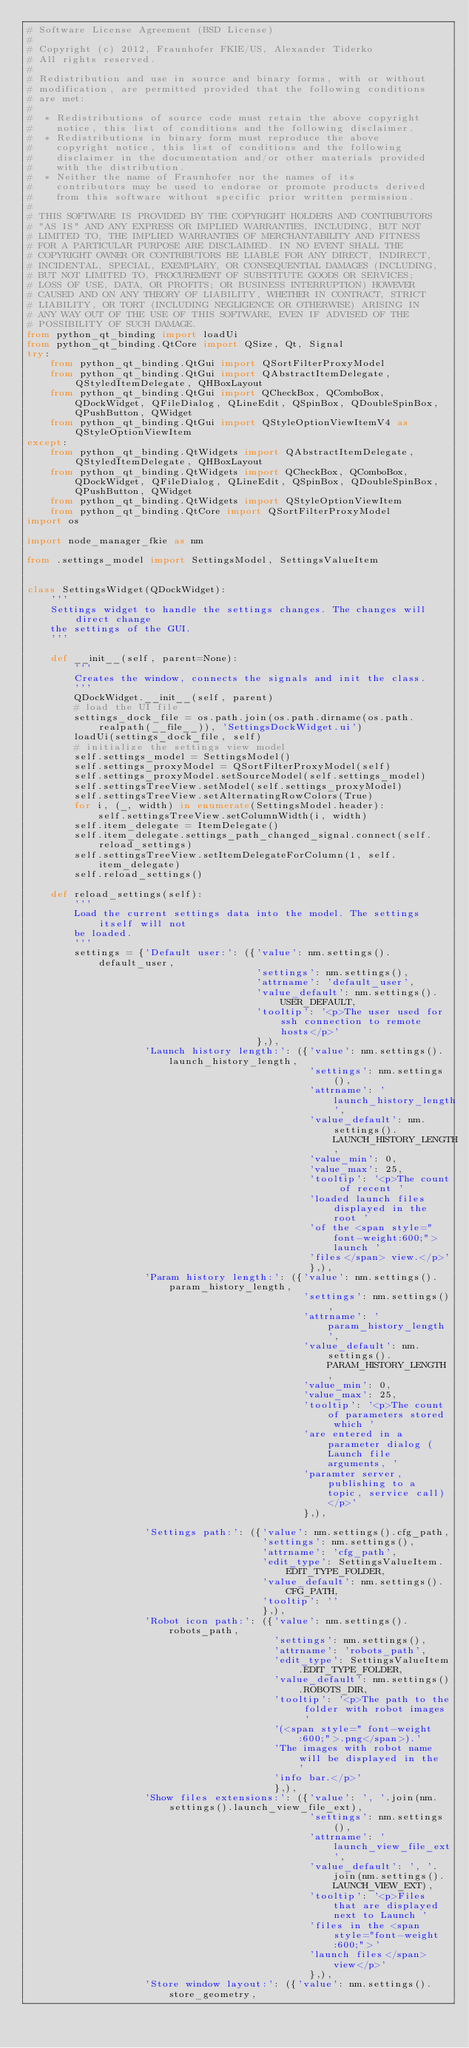<code> <loc_0><loc_0><loc_500><loc_500><_Python_># Software License Agreement (BSD License)
#
# Copyright (c) 2012, Fraunhofer FKIE/US, Alexander Tiderko
# All rights reserved.
#
# Redistribution and use in source and binary forms, with or without
# modification, are permitted provided that the following conditions
# are met:
#
#  * Redistributions of source code must retain the above copyright
#    notice, this list of conditions and the following disclaimer.
#  * Redistributions in binary form must reproduce the above
#    copyright notice, this list of conditions and the following
#    disclaimer in the documentation and/or other materials provided
#    with the distribution.
#  * Neither the name of Fraunhofer nor the names of its
#    contributors may be used to endorse or promote products derived
#    from this software without specific prior written permission.
#
# THIS SOFTWARE IS PROVIDED BY THE COPYRIGHT HOLDERS AND CONTRIBUTORS
# "AS IS" AND ANY EXPRESS OR IMPLIED WARRANTIES, INCLUDING, BUT NOT
# LIMITED TO, THE IMPLIED WARRANTIES OF MERCHANTABILITY AND FITNESS
# FOR A PARTICULAR PURPOSE ARE DISCLAIMED. IN NO EVENT SHALL THE
# COPYRIGHT OWNER OR CONTRIBUTORS BE LIABLE FOR ANY DIRECT, INDIRECT,
# INCIDENTAL, SPECIAL, EXEMPLARY, OR CONSEQUENTIAL DAMAGES (INCLUDING,
# BUT NOT LIMITED TO, PROCUREMENT OF SUBSTITUTE GOODS OR SERVICES;
# LOSS OF USE, DATA, OR PROFITS; OR BUSINESS INTERRUPTION) HOWEVER
# CAUSED AND ON ANY THEORY OF LIABILITY, WHETHER IN CONTRACT, STRICT
# LIABILITY, OR TORT (INCLUDING NEGLIGENCE OR OTHERWISE) ARISING IN
# ANY WAY OUT OF THE USE OF THIS SOFTWARE, EVEN IF ADVISED OF THE
# POSSIBILITY OF SUCH DAMAGE.
from python_qt_binding import loadUi
from python_qt_binding.QtCore import QSize, Qt, Signal
try:
    from python_qt_binding.QtGui import QSortFilterProxyModel
    from python_qt_binding.QtGui import QAbstractItemDelegate, QStyledItemDelegate, QHBoxLayout
    from python_qt_binding.QtGui import QCheckBox, QComboBox, QDockWidget, QFileDialog, QLineEdit, QSpinBox, QDoubleSpinBox, QPushButton, QWidget
    from python_qt_binding.QtGui import QStyleOptionViewItemV4 as QStyleOptionViewItem
except:
    from python_qt_binding.QtWidgets import QAbstractItemDelegate, QStyledItemDelegate, QHBoxLayout
    from python_qt_binding.QtWidgets import QCheckBox, QComboBox, QDockWidget, QFileDialog, QLineEdit, QSpinBox, QDoubleSpinBox, QPushButton, QWidget
    from python_qt_binding.QtWidgets import QStyleOptionViewItem
    from python_qt_binding.QtCore import QSortFilterProxyModel
import os

import node_manager_fkie as nm

from .settings_model import SettingsModel, SettingsValueItem


class SettingsWidget(QDockWidget):
    '''
    Settings widget to handle the settings changes. The changes will direct change
    the settings of the GUI.
    '''

    def __init__(self, parent=None):
        '''
        Creates the window, connects the signals and init the class.
        '''
        QDockWidget.__init__(self, parent)
        # load the UI file
        settings_dock_file = os.path.join(os.path.dirname(os.path.realpath(__file__)), 'SettingsDockWidget.ui')
        loadUi(settings_dock_file, self)
        # initialize the settings view model
        self.settings_model = SettingsModel()
        self.settings_proxyModel = QSortFilterProxyModel(self)
        self.settings_proxyModel.setSourceModel(self.settings_model)
        self.settingsTreeView.setModel(self.settings_proxyModel)
        self.settingsTreeView.setAlternatingRowColors(True)
        for i, (_, width) in enumerate(SettingsModel.header):
            self.settingsTreeView.setColumnWidth(i, width)
        self.item_delegate = ItemDelegate()
        self.item_delegate.settings_path_changed_signal.connect(self.reload_settings)
        self.settingsTreeView.setItemDelegateForColumn(1, self.item_delegate)
        self.reload_settings()

    def reload_settings(self):
        '''
        Load the current settings data into the model. The settings itself will not
        be loaded.
        '''
        settings = {'Default user:': ({'value': nm.settings().default_user,
                                       'settings': nm.settings(),
                                       'attrname': 'default_user',
                                       'value_default': nm.settings().USER_DEFAULT,
                                       'tooltip': '<p>The user used for ssh connection to remote hosts</p>'
                                       },),
                    'Launch history length:': ({'value': nm.settings().launch_history_length,
                                                'settings': nm.settings(),
                                                'attrname': 'launch_history_length',
                                                'value_default': nm.settings().LAUNCH_HISTORY_LENGTH,
                                                'value_min': 0,
                                                'value_max': 25,
                                                'tooltip': '<p>The count of recent '
                                                'loaded launch files displayed in the root '
                                                'of the <span style=" font-weight:600;">launch '
                                                'files</span> view.</p>'
                                                },),
                    'Param history length:': ({'value': nm.settings().param_history_length,
                                               'settings': nm.settings(),
                                               'attrname': 'param_history_length',
                                               'value_default': nm.settings().PARAM_HISTORY_LENGTH,
                                               'value_min': 0,
                                               'value_max': 25,
                                               'tooltip': '<p>The count of parameters stored which '
                                               'are entered in a parameter dialog (Launch file arguments, '
                                               'paramter server, publishing to a topic, service call)</p>'
                                               },),

                    'Settings path:': ({'value': nm.settings().cfg_path,
                                        'settings': nm.settings(),
                                        'attrname': 'cfg_path',
                                        'edit_type': SettingsValueItem.EDIT_TYPE_FOLDER,
                                        'value_default': nm.settings().CFG_PATH,
                                        'tooltip': ''
                                        },),
                    'Robot icon path:': ({'value': nm.settings().robots_path,
                                          'settings': nm.settings(),
                                          'attrname': 'robots_path',
                                          'edit_type': SettingsValueItem.EDIT_TYPE_FOLDER,
                                          'value_default': nm.settings().ROBOTS_DIR,
                                          'tooltip': '<p>The path to the folder with robot images '
                                          '(<span style=" font-weight:600;">.png</span>).'
                                          'The images with robot name will be displayed in the '
                                          'info bar.</p>'
                                          },),
                    'Show files extensions:': ({'value': ', '.join(nm.settings().launch_view_file_ext),
                                                'settings': nm.settings(),
                                                'attrname': 'launch_view_file_ext',
                                                'value_default': ', '.join(nm.settings().LAUNCH_VIEW_EXT),
                                                'tooltip': '<p>Files that are displayed next to Launch '
                                                'files in the <span style="font-weight:600;">'
                                                'launch files</span> view</p>'
                                                },),
                    'Store window layout:': ({'value': nm.settings().store_geometry,</code> 